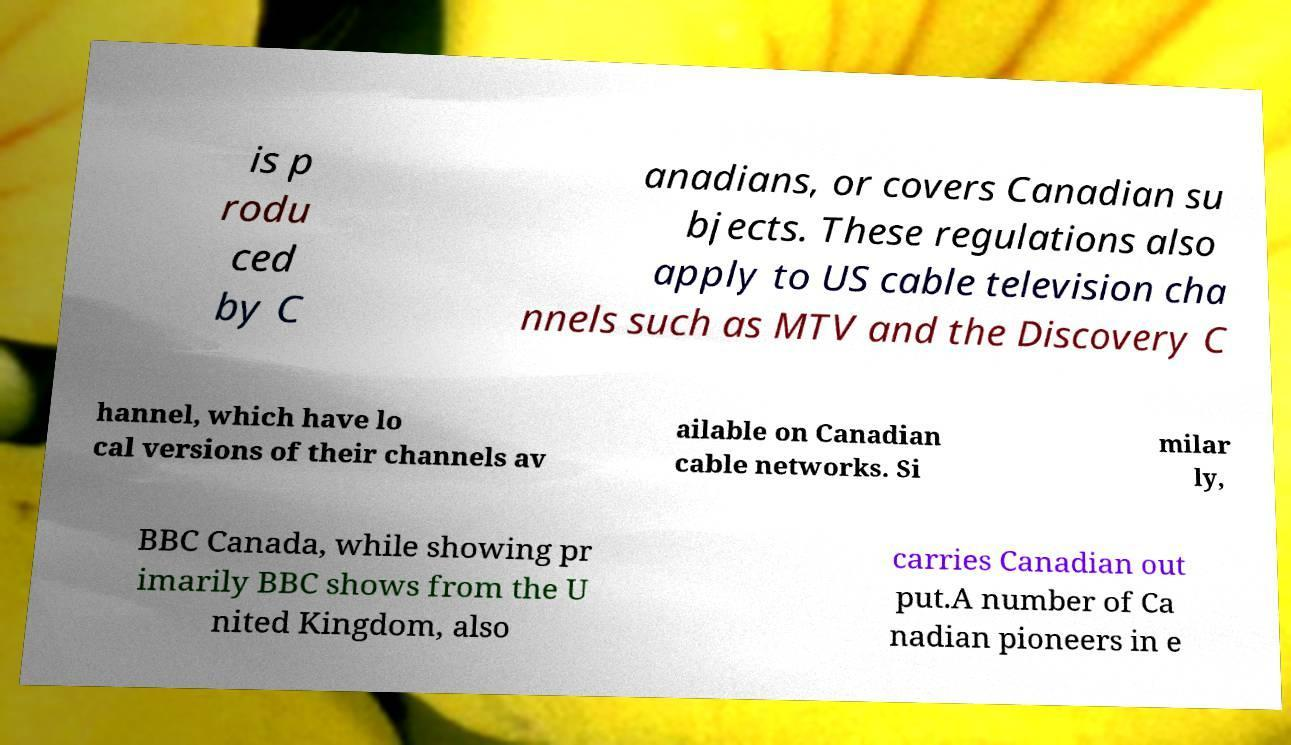I need the written content from this picture converted into text. Can you do that? is p rodu ced by C anadians, or covers Canadian su bjects. These regulations also apply to US cable television cha nnels such as MTV and the Discovery C hannel, which have lo cal versions of their channels av ailable on Canadian cable networks. Si milar ly, BBC Canada, while showing pr imarily BBC shows from the U nited Kingdom, also carries Canadian out put.A number of Ca nadian pioneers in e 